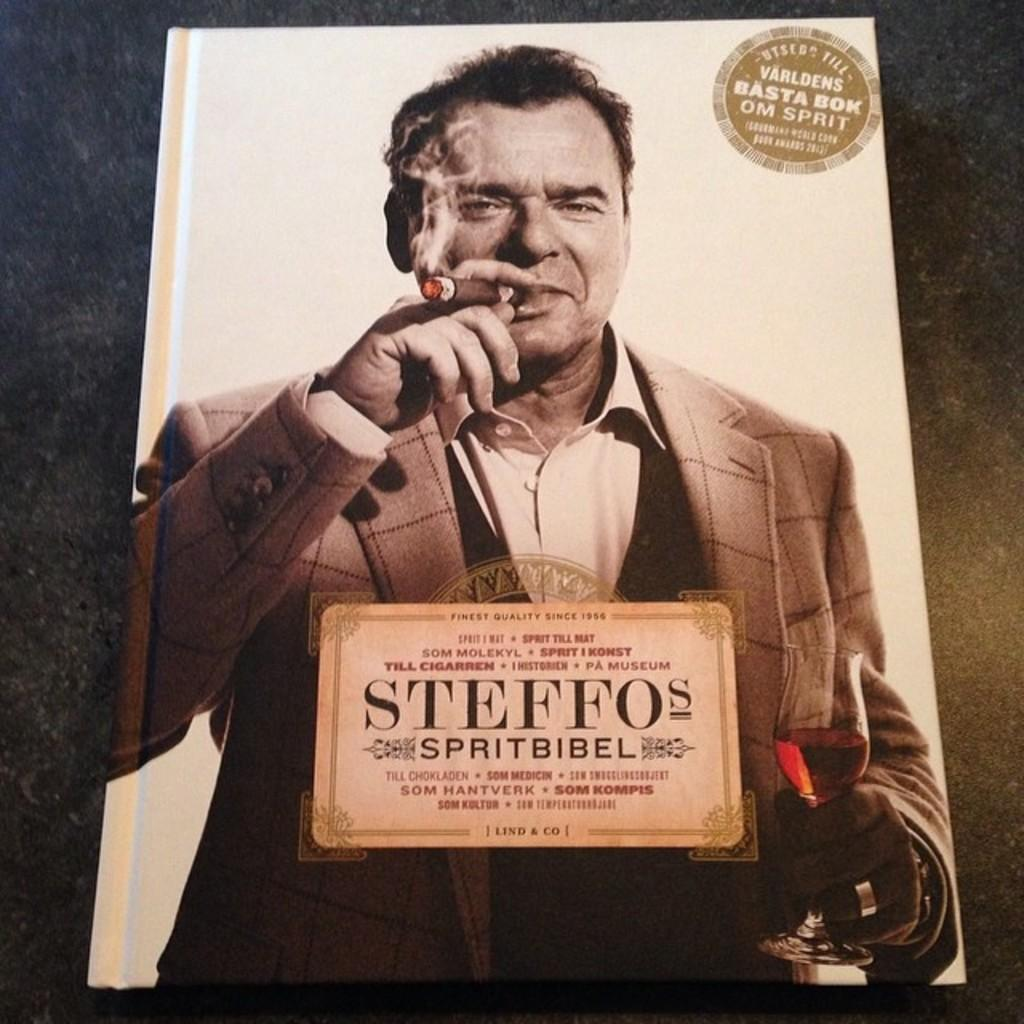What is the color scheme of the image? The image is in black and white. Who is present in the image? There is a man in the image. What is the man doing in the image? The man is smoking. What type of clothing is the man wearing in the image? The man is wearing a coat and a shirt. Reasoning: Let' Let's think step by step in order to produce the conversation. We start by identifying the color scheme of the image, which is black and white. Then, we focus on the main subject in the image, which is the man. We describe his actions and clothing to provide a clear picture of the scene. Each question is designed to elicit a specific detail about the image that is known from the provided facts. Absurd Question/Answer: What type of robin can be seen perched on the man's shoulder in the image? There is no robin present in the image; it only features a man smoking while wearing a coat and a shirt. What is the man's opinion on the part of the city he is standing in, as seen in the image? The image does not provide any information about the man's opinion or the part of the city he is standing in. 